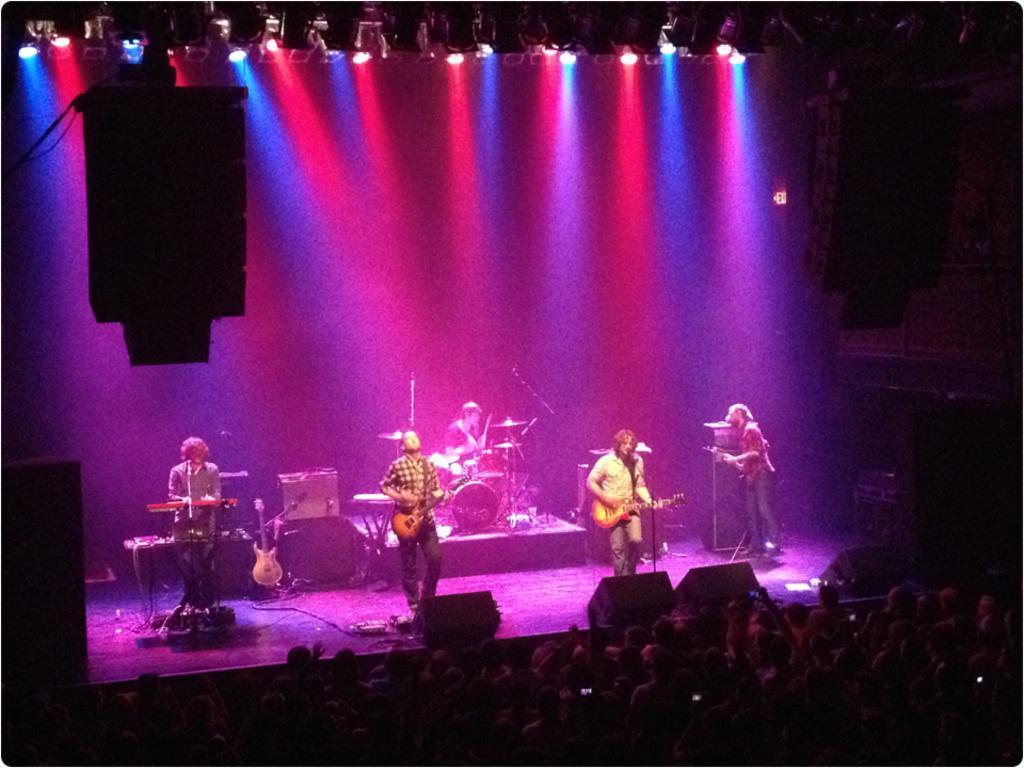Could you give a brief overview of what you see in this image? In this picture we can see some boys standing on the stage and playing guitar and music. In the front there are some audience sitting and watching them. In the background we can see some colorful spotlights. 